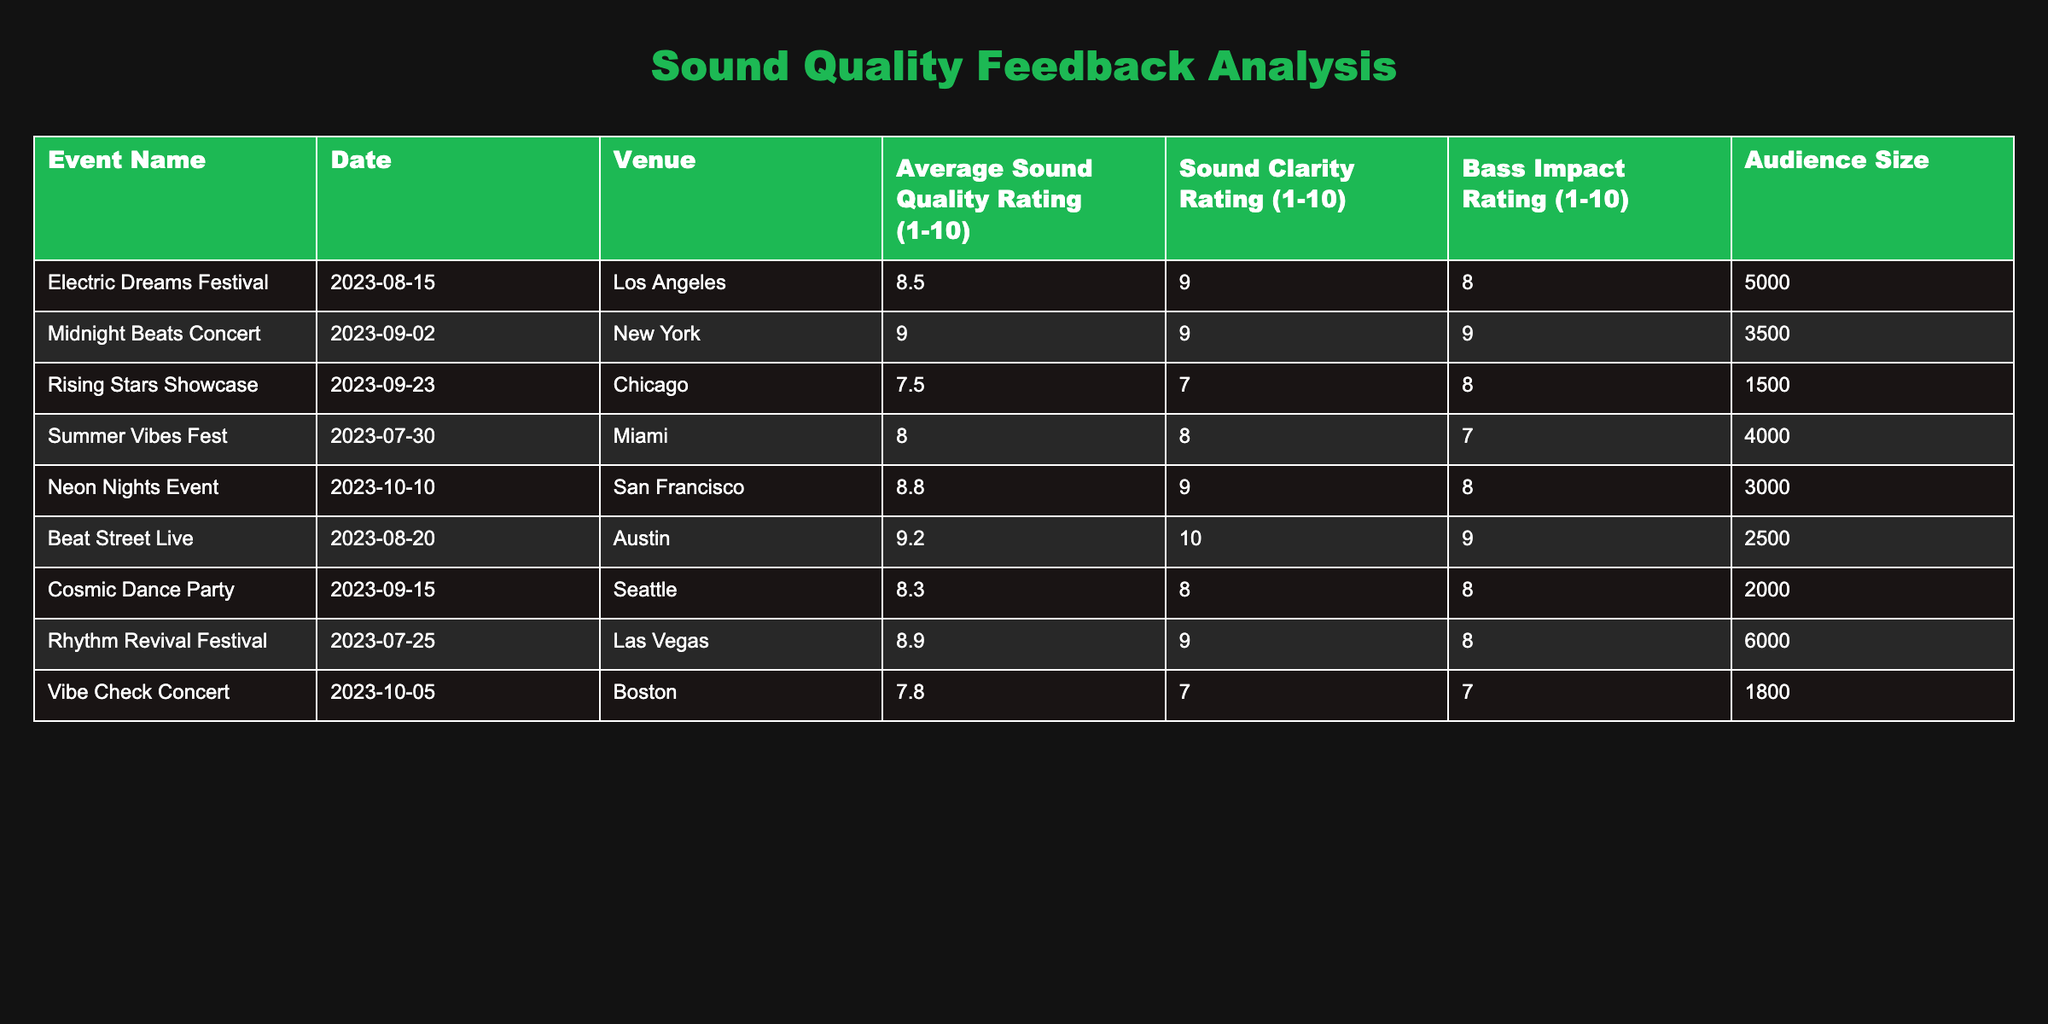What is the average sound quality rating from all the events listed? To calculate the average sound quality rating, we sum up all the average ratings: (8.5 + 9.0 + 7.5 + 8.0 + 8.8 + 9.2 + 8.3 + 8.9 + 7.8) = 78.0. Since there are 9 events, we divide the total by 9 to get the average: 78.0 / 9 = 8.67.
Answer: 8.67 Which event had the highest bass impact rating? The table shows the bass impact ratings for each event. The maximum rating is found for the "Beat Street Live" event with a bass impact rating of 9.
Answer: Beat Street Live How many events had an audience size greater than 4000? By referencing the audience size column, we can see that "Electric Dreams Festival" (5000), "Rhythm Revival Festival" (6000), and "Summer Vibes Fest" (4000) had an audience size of 4000 or more. Thus, there are 3 events in total.
Answer: 3 Is the average sound quality rating for events held in New York higher than the events held in Miami? The average sound quality rating for the "Midnight Beats Concert" in New York is 9.0, while the "Summer Vibes Fest" in Miami has a rating of 8.0. Since 9.0 is greater than 8.0, the statement is true.
Answer: Yes What is the difference between the highest and lowest sound clarity ratings? The highest sound clarity rating is 10 from "Beat Street Live", and the lowest is 7 from both "Rising Stars Showcase" and "Vibe Check Concert". The difference is thus calculated as 10 - 7 = 3.
Answer: 3 What percentage of the events had a sound quality rating of 8 or higher? Counting the number of events with sound quality ratings of 8 or above, we identify 6 events: "Electric Dreams Festival", "Midnight Beats Concert", "Summer Vibes Fest", "Neon Nights Event", "Beat Street Live", and "Rhythm Revival Festival". Out of 9 total events, the percentage is calculated as (6/9)*100 = 66.67%.
Answer: 66.67% Was the average bass impact for events in San Francisco lower than the average for those in Chicago? The "Neon Nights Event" in San Francisco has a bass impact rating of 8, while the "Rising Stars Showcase" in Chicago has a rating of 8. Therefore, the averages are equal, and the statement is false.
Answer: No Which city hosted the event with the lowest audience size and what was that size? The event with the lowest audience size is the "Vibe Check Concert" held in Boston with an audience of 1800.
Answer: 1800 